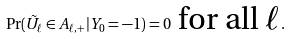<formula> <loc_0><loc_0><loc_500><loc_500>\Pr ( \tilde { U } _ { \ell } \in A _ { \ell , + } | Y _ { 0 } = - 1 ) = 0 \ \text {for all $\ell$} .</formula> 